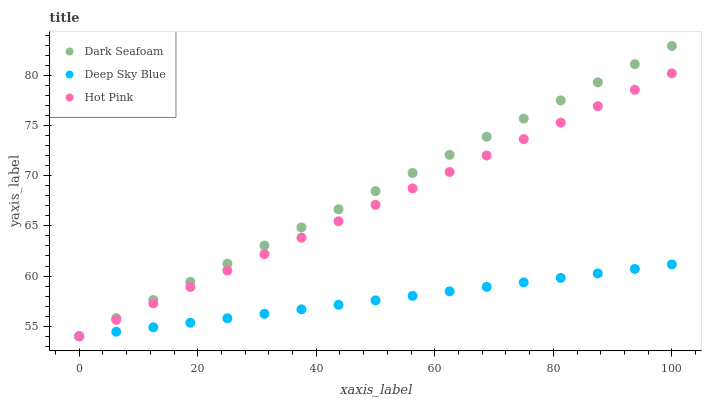Does Deep Sky Blue have the minimum area under the curve?
Answer yes or no. Yes. Does Dark Seafoam have the maximum area under the curve?
Answer yes or no. Yes. Does Hot Pink have the minimum area under the curve?
Answer yes or no. No. Does Hot Pink have the maximum area under the curve?
Answer yes or no. No. Is Deep Sky Blue the smoothest?
Answer yes or no. Yes. Is Dark Seafoam the roughest?
Answer yes or no. Yes. Is Hot Pink the smoothest?
Answer yes or no. No. Is Hot Pink the roughest?
Answer yes or no. No. Does Dark Seafoam have the lowest value?
Answer yes or no. Yes. Does Dark Seafoam have the highest value?
Answer yes or no. Yes. Does Hot Pink have the highest value?
Answer yes or no. No. Does Dark Seafoam intersect Hot Pink?
Answer yes or no. Yes. Is Dark Seafoam less than Hot Pink?
Answer yes or no. No. Is Dark Seafoam greater than Hot Pink?
Answer yes or no. No. 